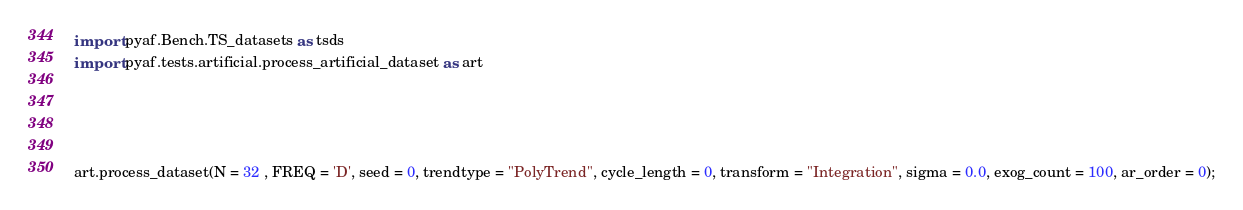<code> <loc_0><loc_0><loc_500><loc_500><_Python_>import pyaf.Bench.TS_datasets as tsds
import pyaf.tests.artificial.process_artificial_dataset as art




art.process_dataset(N = 32 , FREQ = 'D', seed = 0, trendtype = "PolyTrend", cycle_length = 0, transform = "Integration", sigma = 0.0, exog_count = 100, ar_order = 0);</code> 